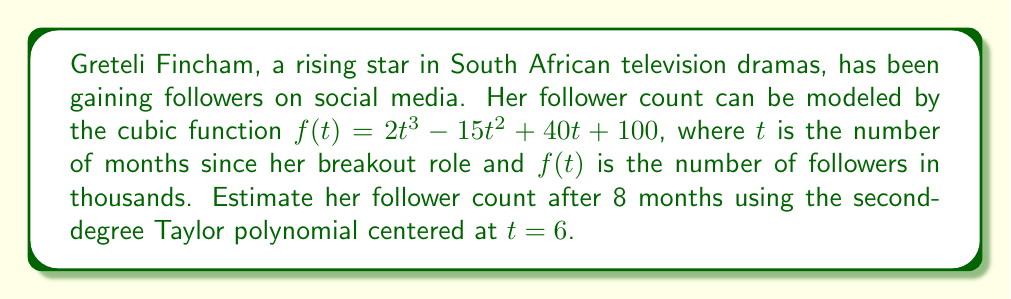Can you answer this question? To estimate Greteli Fincham's follower count after 8 months using the second-degree Taylor polynomial centered at $t = 6$, we need to follow these steps:

1) The general form of a second-degree Taylor polynomial $P_2(t)$ centered at $a$ is:

   $$P_2(t) = f(a) + f'(a)(t-a) + \frac{f''(a)}{2!}(t-a)^2$$

2) We need to find $f(6)$, $f'(6)$, and $f''(6)$:

   $f(t) = 2t^3 - 15t^2 + 40t + 100$
   $f'(t) = 6t^2 - 30t + 40$
   $f''(t) = 12t - 30$

3) Calculate the values:

   $f(6) = 2(6^3) - 15(6^2) + 40(6) + 100 = 432 - 540 + 240 + 100 = 232$
   $f'(6) = 6(6^2) - 30(6) + 40 = 216 - 180 + 40 = 76$
   $f''(6) = 12(6) - 30 = 42$

4) Substitute these values into the Taylor polynomial:

   $$P_2(t) = 232 + 76(t-6) + \frac{42}{2}(t-6)^2$$

5) Simplify:

   $$P_2(t) = 232 + 76(t-6) + 21(t-6)^2$$

6) To estimate the follower count at 8 months, we evaluate $P_2(8)$:

   $$P_2(8) = 232 + 76(2) + 21(2)^2$$
   $$= 232 + 152 + 84$$
   $$= 468$$

Therefore, the estimated follower count after 8 months is 468 thousand.
Answer: 468 thousand followers 